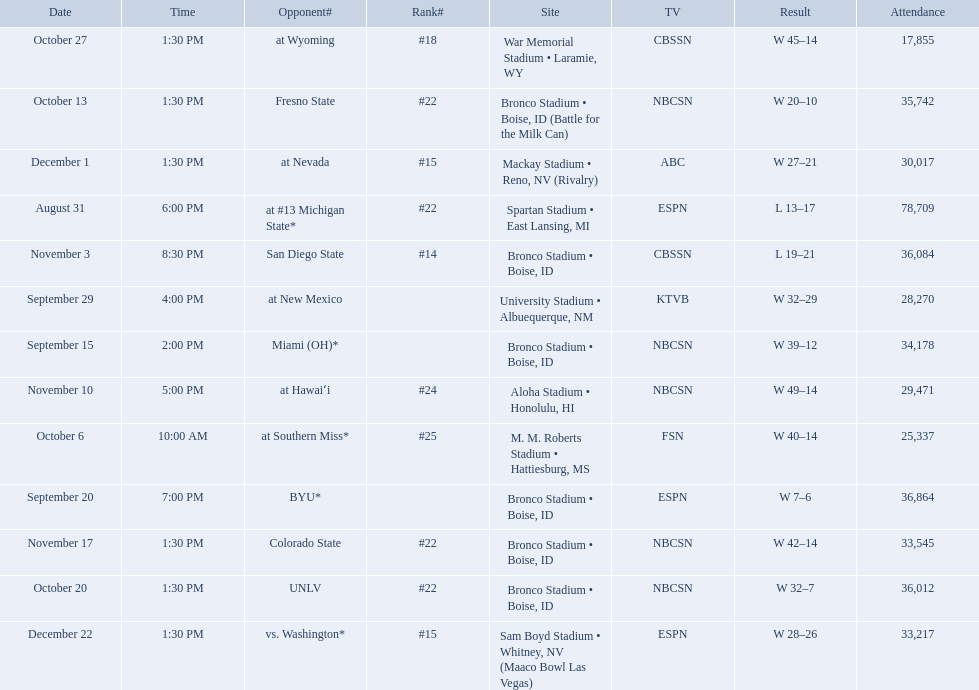What are all of the rankings? #22, , , , #25, #22, #22, #18, #14, #24, #22, #15, #15. Which of them was the best position? #14. 